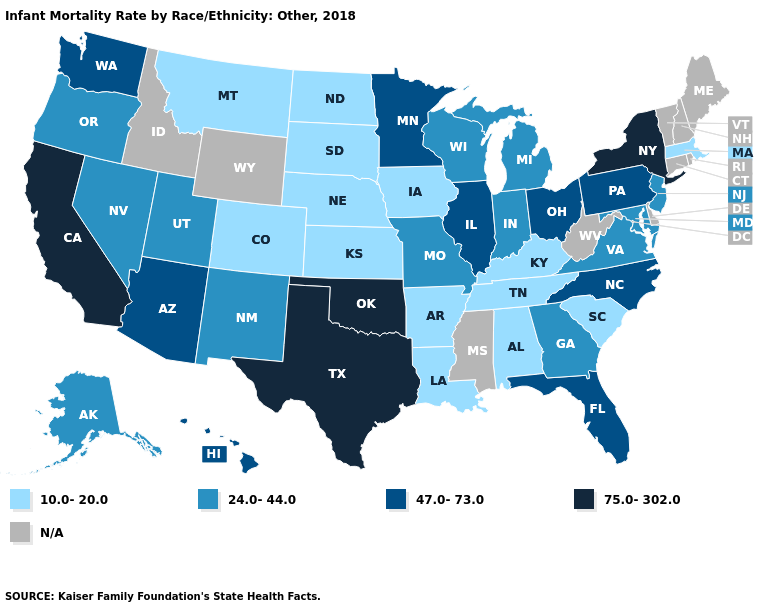What is the value of Oregon?
Short answer required. 24.0-44.0. What is the value of Arizona?
Quick response, please. 47.0-73.0. Among the states that border Pennsylvania , which have the highest value?
Answer briefly. New York. What is the lowest value in the USA?
Keep it brief. 10.0-20.0. Name the states that have a value in the range 47.0-73.0?
Write a very short answer. Arizona, Florida, Hawaii, Illinois, Minnesota, North Carolina, Ohio, Pennsylvania, Washington. What is the value of Utah?
Answer briefly. 24.0-44.0. Name the states that have a value in the range N/A?
Short answer required. Connecticut, Delaware, Idaho, Maine, Mississippi, New Hampshire, Rhode Island, Vermont, West Virginia, Wyoming. Does the map have missing data?
Write a very short answer. Yes. Name the states that have a value in the range 75.0-302.0?
Quick response, please. California, New York, Oklahoma, Texas. What is the value of North Carolina?
Give a very brief answer. 47.0-73.0. What is the lowest value in the USA?
Give a very brief answer. 10.0-20.0. Which states have the highest value in the USA?
Be succinct. California, New York, Oklahoma, Texas. What is the value of Rhode Island?
Answer briefly. N/A. What is the lowest value in states that border California?
Quick response, please. 24.0-44.0. 